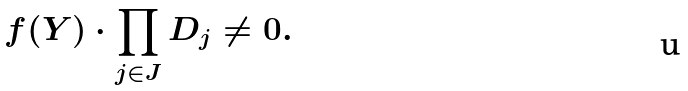<formula> <loc_0><loc_0><loc_500><loc_500>f ( Y ) \cdot \prod _ { j \in J } D _ { j } \ne 0 .</formula> 